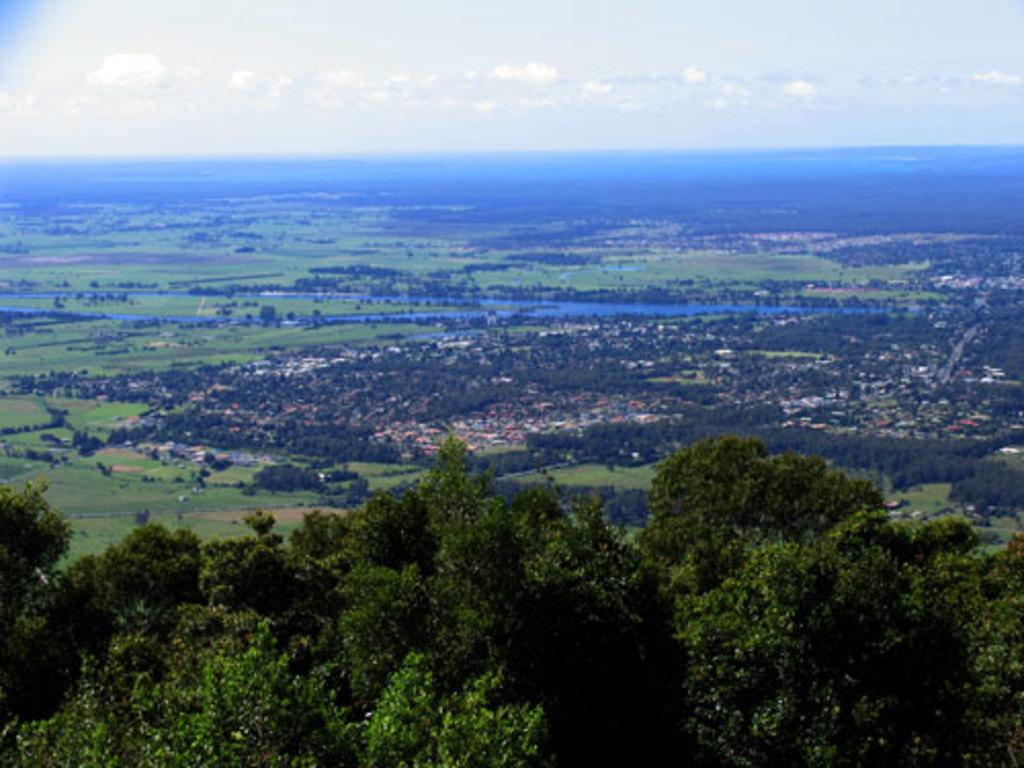What type of structures can be seen in the image? There are buildings in the image. What type of vegetation is present in the image? There are trees and small plants in the image. What is visible on the ground in the image? The ground is visible in the image. What body of water can be seen in the image? There is a river in the image. What part of the natural environment is visible in the image? The sky is visible in the image. What can be observed in the sky? There are clouds in the sky. Can you see a pet carrying a basket in the image? There is no pet carrying a basket present in the image. What type of heart-shaped object can be seen in the image? There is no heart-shaped object present in the image. 